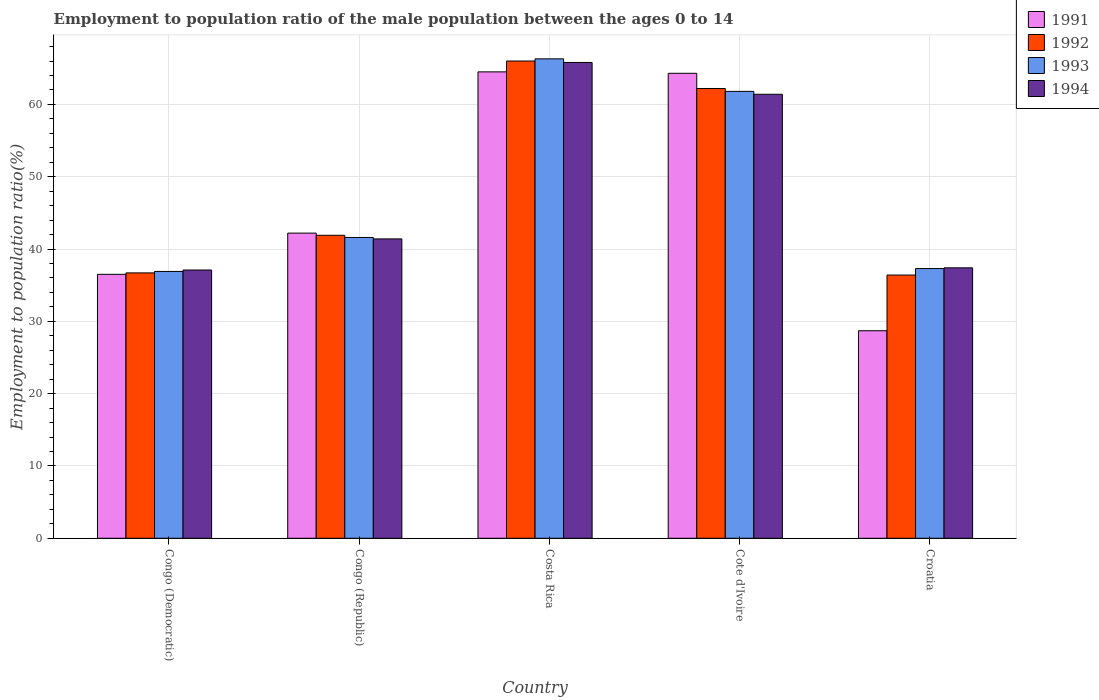How many different coloured bars are there?
Give a very brief answer. 4. Are the number of bars per tick equal to the number of legend labels?
Provide a succinct answer. Yes. What is the label of the 1st group of bars from the left?
Your response must be concise. Congo (Democratic). What is the employment to population ratio in 1992 in Congo (Democratic)?
Keep it short and to the point. 36.7. Across all countries, what is the minimum employment to population ratio in 1992?
Provide a short and direct response. 36.4. In which country was the employment to population ratio in 1993 maximum?
Give a very brief answer. Costa Rica. In which country was the employment to population ratio in 1991 minimum?
Provide a succinct answer. Croatia. What is the total employment to population ratio in 1991 in the graph?
Offer a terse response. 236.2. What is the difference between the employment to population ratio in 1991 in Costa Rica and that in Cote d'Ivoire?
Your answer should be compact. 0.2. What is the difference between the employment to population ratio in 1992 in Croatia and the employment to population ratio in 1991 in Costa Rica?
Give a very brief answer. -28.1. What is the average employment to population ratio in 1994 per country?
Your answer should be compact. 48.62. What is the difference between the employment to population ratio of/in 1994 and employment to population ratio of/in 1992 in Costa Rica?
Provide a short and direct response. -0.2. In how many countries, is the employment to population ratio in 1994 greater than 2 %?
Give a very brief answer. 5. What is the ratio of the employment to population ratio in 1991 in Costa Rica to that in Croatia?
Make the answer very short. 2.25. Is the employment to population ratio in 1992 in Costa Rica less than that in Croatia?
Offer a very short reply. No. What is the difference between the highest and the second highest employment to population ratio in 1991?
Keep it short and to the point. 22.3. What is the difference between the highest and the lowest employment to population ratio in 1993?
Your answer should be very brief. 29.4. Is it the case that in every country, the sum of the employment to population ratio in 1991 and employment to population ratio in 1992 is greater than the sum of employment to population ratio in 1994 and employment to population ratio in 1993?
Your answer should be very brief. No. How many countries are there in the graph?
Give a very brief answer. 5. What is the difference between two consecutive major ticks on the Y-axis?
Your response must be concise. 10. How are the legend labels stacked?
Offer a terse response. Vertical. What is the title of the graph?
Your response must be concise. Employment to population ratio of the male population between the ages 0 to 14. What is the label or title of the Y-axis?
Your answer should be very brief. Employment to population ratio(%). What is the Employment to population ratio(%) in 1991 in Congo (Democratic)?
Make the answer very short. 36.5. What is the Employment to population ratio(%) in 1992 in Congo (Democratic)?
Make the answer very short. 36.7. What is the Employment to population ratio(%) in 1993 in Congo (Democratic)?
Your response must be concise. 36.9. What is the Employment to population ratio(%) in 1994 in Congo (Democratic)?
Your answer should be very brief. 37.1. What is the Employment to population ratio(%) in 1991 in Congo (Republic)?
Offer a very short reply. 42.2. What is the Employment to population ratio(%) of 1992 in Congo (Republic)?
Your response must be concise. 41.9. What is the Employment to population ratio(%) of 1993 in Congo (Republic)?
Ensure brevity in your answer.  41.6. What is the Employment to population ratio(%) in 1994 in Congo (Republic)?
Your response must be concise. 41.4. What is the Employment to population ratio(%) in 1991 in Costa Rica?
Ensure brevity in your answer.  64.5. What is the Employment to population ratio(%) of 1992 in Costa Rica?
Keep it short and to the point. 66. What is the Employment to population ratio(%) in 1993 in Costa Rica?
Ensure brevity in your answer.  66.3. What is the Employment to population ratio(%) in 1994 in Costa Rica?
Offer a terse response. 65.8. What is the Employment to population ratio(%) of 1991 in Cote d'Ivoire?
Provide a short and direct response. 64.3. What is the Employment to population ratio(%) of 1992 in Cote d'Ivoire?
Ensure brevity in your answer.  62.2. What is the Employment to population ratio(%) of 1993 in Cote d'Ivoire?
Offer a very short reply. 61.8. What is the Employment to population ratio(%) in 1994 in Cote d'Ivoire?
Provide a succinct answer. 61.4. What is the Employment to population ratio(%) of 1991 in Croatia?
Provide a short and direct response. 28.7. What is the Employment to population ratio(%) in 1992 in Croatia?
Offer a very short reply. 36.4. What is the Employment to population ratio(%) in 1993 in Croatia?
Your response must be concise. 37.3. What is the Employment to population ratio(%) of 1994 in Croatia?
Your answer should be compact. 37.4. Across all countries, what is the maximum Employment to population ratio(%) of 1991?
Your answer should be very brief. 64.5. Across all countries, what is the maximum Employment to population ratio(%) of 1993?
Your answer should be compact. 66.3. Across all countries, what is the maximum Employment to population ratio(%) of 1994?
Provide a short and direct response. 65.8. Across all countries, what is the minimum Employment to population ratio(%) in 1991?
Your response must be concise. 28.7. Across all countries, what is the minimum Employment to population ratio(%) in 1992?
Your response must be concise. 36.4. Across all countries, what is the minimum Employment to population ratio(%) of 1993?
Ensure brevity in your answer.  36.9. Across all countries, what is the minimum Employment to population ratio(%) of 1994?
Offer a terse response. 37.1. What is the total Employment to population ratio(%) in 1991 in the graph?
Your answer should be compact. 236.2. What is the total Employment to population ratio(%) of 1992 in the graph?
Your answer should be very brief. 243.2. What is the total Employment to population ratio(%) of 1993 in the graph?
Ensure brevity in your answer.  243.9. What is the total Employment to population ratio(%) in 1994 in the graph?
Your response must be concise. 243.1. What is the difference between the Employment to population ratio(%) of 1992 in Congo (Democratic) and that in Congo (Republic)?
Provide a succinct answer. -5.2. What is the difference between the Employment to population ratio(%) of 1991 in Congo (Democratic) and that in Costa Rica?
Provide a short and direct response. -28. What is the difference between the Employment to population ratio(%) of 1992 in Congo (Democratic) and that in Costa Rica?
Offer a very short reply. -29.3. What is the difference between the Employment to population ratio(%) in 1993 in Congo (Democratic) and that in Costa Rica?
Offer a terse response. -29.4. What is the difference between the Employment to population ratio(%) of 1994 in Congo (Democratic) and that in Costa Rica?
Offer a very short reply. -28.7. What is the difference between the Employment to population ratio(%) in 1991 in Congo (Democratic) and that in Cote d'Ivoire?
Your answer should be compact. -27.8. What is the difference between the Employment to population ratio(%) in 1992 in Congo (Democratic) and that in Cote d'Ivoire?
Provide a short and direct response. -25.5. What is the difference between the Employment to population ratio(%) of 1993 in Congo (Democratic) and that in Cote d'Ivoire?
Make the answer very short. -24.9. What is the difference between the Employment to population ratio(%) of 1994 in Congo (Democratic) and that in Cote d'Ivoire?
Provide a succinct answer. -24.3. What is the difference between the Employment to population ratio(%) in 1991 in Congo (Democratic) and that in Croatia?
Your response must be concise. 7.8. What is the difference between the Employment to population ratio(%) of 1993 in Congo (Democratic) and that in Croatia?
Make the answer very short. -0.4. What is the difference between the Employment to population ratio(%) in 1991 in Congo (Republic) and that in Costa Rica?
Provide a succinct answer. -22.3. What is the difference between the Employment to population ratio(%) of 1992 in Congo (Republic) and that in Costa Rica?
Offer a terse response. -24.1. What is the difference between the Employment to population ratio(%) of 1993 in Congo (Republic) and that in Costa Rica?
Ensure brevity in your answer.  -24.7. What is the difference between the Employment to population ratio(%) of 1994 in Congo (Republic) and that in Costa Rica?
Keep it short and to the point. -24.4. What is the difference between the Employment to population ratio(%) in 1991 in Congo (Republic) and that in Cote d'Ivoire?
Provide a short and direct response. -22.1. What is the difference between the Employment to population ratio(%) of 1992 in Congo (Republic) and that in Cote d'Ivoire?
Offer a terse response. -20.3. What is the difference between the Employment to population ratio(%) in 1993 in Congo (Republic) and that in Cote d'Ivoire?
Your answer should be compact. -20.2. What is the difference between the Employment to population ratio(%) of 1992 in Congo (Republic) and that in Croatia?
Your answer should be compact. 5.5. What is the difference between the Employment to population ratio(%) in 1993 in Congo (Republic) and that in Croatia?
Offer a very short reply. 4.3. What is the difference between the Employment to population ratio(%) in 1992 in Costa Rica and that in Cote d'Ivoire?
Provide a succinct answer. 3.8. What is the difference between the Employment to population ratio(%) of 1993 in Costa Rica and that in Cote d'Ivoire?
Ensure brevity in your answer.  4.5. What is the difference between the Employment to population ratio(%) in 1991 in Costa Rica and that in Croatia?
Keep it short and to the point. 35.8. What is the difference between the Employment to population ratio(%) of 1992 in Costa Rica and that in Croatia?
Your response must be concise. 29.6. What is the difference between the Employment to population ratio(%) of 1994 in Costa Rica and that in Croatia?
Ensure brevity in your answer.  28.4. What is the difference between the Employment to population ratio(%) of 1991 in Cote d'Ivoire and that in Croatia?
Ensure brevity in your answer.  35.6. What is the difference between the Employment to population ratio(%) in 1992 in Cote d'Ivoire and that in Croatia?
Provide a short and direct response. 25.8. What is the difference between the Employment to population ratio(%) in 1993 in Cote d'Ivoire and that in Croatia?
Your answer should be compact. 24.5. What is the difference between the Employment to population ratio(%) of 1991 in Congo (Democratic) and the Employment to population ratio(%) of 1992 in Congo (Republic)?
Make the answer very short. -5.4. What is the difference between the Employment to population ratio(%) in 1991 in Congo (Democratic) and the Employment to population ratio(%) in 1993 in Congo (Republic)?
Give a very brief answer. -5.1. What is the difference between the Employment to population ratio(%) of 1992 in Congo (Democratic) and the Employment to population ratio(%) of 1993 in Congo (Republic)?
Your answer should be very brief. -4.9. What is the difference between the Employment to population ratio(%) in 1992 in Congo (Democratic) and the Employment to population ratio(%) in 1994 in Congo (Republic)?
Give a very brief answer. -4.7. What is the difference between the Employment to population ratio(%) of 1991 in Congo (Democratic) and the Employment to population ratio(%) of 1992 in Costa Rica?
Keep it short and to the point. -29.5. What is the difference between the Employment to population ratio(%) of 1991 in Congo (Democratic) and the Employment to population ratio(%) of 1993 in Costa Rica?
Make the answer very short. -29.8. What is the difference between the Employment to population ratio(%) in 1991 in Congo (Democratic) and the Employment to population ratio(%) in 1994 in Costa Rica?
Provide a short and direct response. -29.3. What is the difference between the Employment to population ratio(%) in 1992 in Congo (Democratic) and the Employment to population ratio(%) in 1993 in Costa Rica?
Ensure brevity in your answer.  -29.6. What is the difference between the Employment to population ratio(%) of 1992 in Congo (Democratic) and the Employment to population ratio(%) of 1994 in Costa Rica?
Offer a very short reply. -29.1. What is the difference between the Employment to population ratio(%) of 1993 in Congo (Democratic) and the Employment to population ratio(%) of 1994 in Costa Rica?
Your answer should be very brief. -28.9. What is the difference between the Employment to population ratio(%) of 1991 in Congo (Democratic) and the Employment to population ratio(%) of 1992 in Cote d'Ivoire?
Offer a very short reply. -25.7. What is the difference between the Employment to population ratio(%) of 1991 in Congo (Democratic) and the Employment to population ratio(%) of 1993 in Cote d'Ivoire?
Provide a short and direct response. -25.3. What is the difference between the Employment to population ratio(%) in 1991 in Congo (Democratic) and the Employment to population ratio(%) in 1994 in Cote d'Ivoire?
Offer a terse response. -24.9. What is the difference between the Employment to population ratio(%) in 1992 in Congo (Democratic) and the Employment to population ratio(%) in 1993 in Cote d'Ivoire?
Provide a succinct answer. -25.1. What is the difference between the Employment to population ratio(%) of 1992 in Congo (Democratic) and the Employment to population ratio(%) of 1994 in Cote d'Ivoire?
Provide a succinct answer. -24.7. What is the difference between the Employment to population ratio(%) of 1993 in Congo (Democratic) and the Employment to population ratio(%) of 1994 in Cote d'Ivoire?
Provide a succinct answer. -24.5. What is the difference between the Employment to population ratio(%) in 1991 in Congo (Democratic) and the Employment to population ratio(%) in 1994 in Croatia?
Give a very brief answer. -0.9. What is the difference between the Employment to population ratio(%) in 1992 in Congo (Democratic) and the Employment to population ratio(%) in 1993 in Croatia?
Give a very brief answer. -0.6. What is the difference between the Employment to population ratio(%) in 1992 in Congo (Democratic) and the Employment to population ratio(%) in 1994 in Croatia?
Keep it short and to the point. -0.7. What is the difference between the Employment to population ratio(%) in 1993 in Congo (Democratic) and the Employment to population ratio(%) in 1994 in Croatia?
Your answer should be compact. -0.5. What is the difference between the Employment to population ratio(%) of 1991 in Congo (Republic) and the Employment to population ratio(%) of 1992 in Costa Rica?
Provide a succinct answer. -23.8. What is the difference between the Employment to population ratio(%) in 1991 in Congo (Republic) and the Employment to population ratio(%) in 1993 in Costa Rica?
Your answer should be very brief. -24.1. What is the difference between the Employment to population ratio(%) of 1991 in Congo (Republic) and the Employment to population ratio(%) of 1994 in Costa Rica?
Provide a short and direct response. -23.6. What is the difference between the Employment to population ratio(%) in 1992 in Congo (Republic) and the Employment to population ratio(%) in 1993 in Costa Rica?
Offer a very short reply. -24.4. What is the difference between the Employment to population ratio(%) of 1992 in Congo (Republic) and the Employment to population ratio(%) of 1994 in Costa Rica?
Make the answer very short. -23.9. What is the difference between the Employment to population ratio(%) in 1993 in Congo (Republic) and the Employment to population ratio(%) in 1994 in Costa Rica?
Ensure brevity in your answer.  -24.2. What is the difference between the Employment to population ratio(%) of 1991 in Congo (Republic) and the Employment to population ratio(%) of 1993 in Cote d'Ivoire?
Your answer should be compact. -19.6. What is the difference between the Employment to population ratio(%) of 1991 in Congo (Republic) and the Employment to population ratio(%) of 1994 in Cote d'Ivoire?
Provide a succinct answer. -19.2. What is the difference between the Employment to population ratio(%) of 1992 in Congo (Republic) and the Employment to population ratio(%) of 1993 in Cote d'Ivoire?
Your response must be concise. -19.9. What is the difference between the Employment to population ratio(%) of 1992 in Congo (Republic) and the Employment to population ratio(%) of 1994 in Cote d'Ivoire?
Provide a succinct answer. -19.5. What is the difference between the Employment to population ratio(%) of 1993 in Congo (Republic) and the Employment to population ratio(%) of 1994 in Cote d'Ivoire?
Give a very brief answer. -19.8. What is the difference between the Employment to population ratio(%) in 1991 in Congo (Republic) and the Employment to population ratio(%) in 1992 in Croatia?
Give a very brief answer. 5.8. What is the difference between the Employment to population ratio(%) in 1991 in Congo (Republic) and the Employment to population ratio(%) in 1993 in Croatia?
Offer a very short reply. 4.9. What is the difference between the Employment to population ratio(%) in 1991 in Costa Rica and the Employment to population ratio(%) in 1992 in Cote d'Ivoire?
Provide a succinct answer. 2.3. What is the difference between the Employment to population ratio(%) in 1991 in Costa Rica and the Employment to population ratio(%) in 1993 in Cote d'Ivoire?
Provide a short and direct response. 2.7. What is the difference between the Employment to population ratio(%) in 1991 in Costa Rica and the Employment to population ratio(%) in 1994 in Cote d'Ivoire?
Make the answer very short. 3.1. What is the difference between the Employment to population ratio(%) of 1993 in Costa Rica and the Employment to population ratio(%) of 1994 in Cote d'Ivoire?
Your answer should be very brief. 4.9. What is the difference between the Employment to population ratio(%) in 1991 in Costa Rica and the Employment to population ratio(%) in 1992 in Croatia?
Offer a terse response. 28.1. What is the difference between the Employment to population ratio(%) in 1991 in Costa Rica and the Employment to population ratio(%) in 1993 in Croatia?
Provide a succinct answer. 27.2. What is the difference between the Employment to population ratio(%) in 1991 in Costa Rica and the Employment to population ratio(%) in 1994 in Croatia?
Your answer should be compact. 27.1. What is the difference between the Employment to population ratio(%) of 1992 in Costa Rica and the Employment to population ratio(%) of 1993 in Croatia?
Your answer should be very brief. 28.7. What is the difference between the Employment to population ratio(%) of 1992 in Costa Rica and the Employment to population ratio(%) of 1994 in Croatia?
Provide a short and direct response. 28.6. What is the difference between the Employment to population ratio(%) in 1993 in Costa Rica and the Employment to population ratio(%) in 1994 in Croatia?
Provide a succinct answer. 28.9. What is the difference between the Employment to population ratio(%) in 1991 in Cote d'Ivoire and the Employment to population ratio(%) in 1992 in Croatia?
Give a very brief answer. 27.9. What is the difference between the Employment to population ratio(%) of 1991 in Cote d'Ivoire and the Employment to population ratio(%) of 1993 in Croatia?
Offer a terse response. 27. What is the difference between the Employment to population ratio(%) of 1991 in Cote d'Ivoire and the Employment to population ratio(%) of 1994 in Croatia?
Your answer should be very brief. 26.9. What is the difference between the Employment to population ratio(%) of 1992 in Cote d'Ivoire and the Employment to population ratio(%) of 1993 in Croatia?
Your answer should be compact. 24.9. What is the difference between the Employment to population ratio(%) in 1992 in Cote d'Ivoire and the Employment to population ratio(%) in 1994 in Croatia?
Your response must be concise. 24.8. What is the difference between the Employment to population ratio(%) in 1993 in Cote d'Ivoire and the Employment to population ratio(%) in 1994 in Croatia?
Provide a succinct answer. 24.4. What is the average Employment to population ratio(%) of 1991 per country?
Your answer should be very brief. 47.24. What is the average Employment to population ratio(%) of 1992 per country?
Keep it short and to the point. 48.64. What is the average Employment to population ratio(%) of 1993 per country?
Offer a very short reply. 48.78. What is the average Employment to population ratio(%) in 1994 per country?
Make the answer very short. 48.62. What is the difference between the Employment to population ratio(%) in 1991 and Employment to population ratio(%) in 1992 in Congo (Democratic)?
Provide a succinct answer. -0.2. What is the difference between the Employment to population ratio(%) in 1991 and Employment to population ratio(%) in 1993 in Congo (Democratic)?
Offer a terse response. -0.4. What is the difference between the Employment to population ratio(%) of 1993 and Employment to population ratio(%) of 1994 in Congo (Democratic)?
Your response must be concise. -0.2. What is the difference between the Employment to population ratio(%) in 1991 and Employment to population ratio(%) in 1993 in Congo (Republic)?
Keep it short and to the point. 0.6. What is the difference between the Employment to population ratio(%) in 1991 and Employment to population ratio(%) in 1993 in Costa Rica?
Keep it short and to the point. -1.8. What is the difference between the Employment to population ratio(%) in 1991 and Employment to population ratio(%) in 1994 in Costa Rica?
Ensure brevity in your answer.  -1.3. What is the difference between the Employment to population ratio(%) in 1992 and Employment to population ratio(%) in 1994 in Costa Rica?
Your answer should be compact. 0.2. What is the difference between the Employment to population ratio(%) in 1993 and Employment to population ratio(%) in 1994 in Costa Rica?
Your response must be concise. 0.5. What is the difference between the Employment to population ratio(%) in 1991 and Employment to population ratio(%) in 1992 in Cote d'Ivoire?
Give a very brief answer. 2.1. What is the difference between the Employment to population ratio(%) in 1991 and Employment to population ratio(%) in 1993 in Cote d'Ivoire?
Provide a succinct answer. 2.5. What is the difference between the Employment to population ratio(%) of 1992 and Employment to population ratio(%) of 1993 in Cote d'Ivoire?
Your answer should be very brief. 0.4. What is the difference between the Employment to population ratio(%) in 1993 and Employment to population ratio(%) in 1994 in Cote d'Ivoire?
Provide a succinct answer. 0.4. What is the difference between the Employment to population ratio(%) of 1991 and Employment to population ratio(%) of 1992 in Croatia?
Your answer should be very brief. -7.7. What is the difference between the Employment to population ratio(%) in 1991 and Employment to population ratio(%) in 1994 in Croatia?
Keep it short and to the point. -8.7. What is the ratio of the Employment to population ratio(%) in 1991 in Congo (Democratic) to that in Congo (Republic)?
Offer a terse response. 0.86. What is the ratio of the Employment to population ratio(%) of 1992 in Congo (Democratic) to that in Congo (Republic)?
Make the answer very short. 0.88. What is the ratio of the Employment to population ratio(%) of 1993 in Congo (Democratic) to that in Congo (Republic)?
Ensure brevity in your answer.  0.89. What is the ratio of the Employment to population ratio(%) in 1994 in Congo (Democratic) to that in Congo (Republic)?
Provide a short and direct response. 0.9. What is the ratio of the Employment to population ratio(%) in 1991 in Congo (Democratic) to that in Costa Rica?
Give a very brief answer. 0.57. What is the ratio of the Employment to population ratio(%) in 1992 in Congo (Democratic) to that in Costa Rica?
Make the answer very short. 0.56. What is the ratio of the Employment to population ratio(%) of 1993 in Congo (Democratic) to that in Costa Rica?
Your response must be concise. 0.56. What is the ratio of the Employment to population ratio(%) of 1994 in Congo (Democratic) to that in Costa Rica?
Offer a terse response. 0.56. What is the ratio of the Employment to population ratio(%) in 1991 in Congo (Democratic) to that in Cote d'Ivoire?
Your answer should be very brief. 0.57. What is the ratio of the Employment to population ratio(%) in 1992 in Congo (Democratic) to that in Cote d'Ivoire?
Ensure brevity in your answer.  0.59. What is the ratio of the Employment to population ratio(%) in 1993 in Congo (Democratic) to that in Cote d'Ivoire?
Provide a succinct answer. 0.6. What is the ratio of the Employment to population ratio(%) of 1994 in Congo (Democratic) to that in Cote d'Ivoire?
Keep it short and to the point. 0.6. What is the ratio of the Employment to population ratio(%) of 1991 in Congo (Democratic) to that in Croatia?
Offer a very short reply. 1.27. What is the ratio of the Employment to population ratio(%) of 1992 in Congo (Democratic) to that in Croatia?
Give a very brief answer. 1.01. What is the ratio of the Employment to population ratio(%) in 1993 in Congo (Democratic) to that in Croatia?
Provide a succinct answer. 0.99. What is the ratio of the Employment to population ratio(%) in 1994 in Congo (Democratic) to that in Croatia?
Offer a terse response. 0.99. What is the ratio of the Employment to population ratio(%) in 1991 in Congo (Republic) to that in Costa Rica?
Make the answer very short. 0.65. What is the ratio of the Employment to population ratio(%) in 1992 in Congo (Republic) to that in Costa Rica?
Make the answer very short. 0.63. What is the ratio of the Employment to population ratio(%) in 1993 in Congo (Republic) to that in Costa Rica?
Provide a short and direct response. 0.63. What is the ratio of the Employment to population ratio(%) of 1994 in Congo (Republic) to that in Costa Rica?
Provide a short and direct response. 0.63. What is the ratio of the Employment to population ratio(%) in 1991 in Congo (Republic) to that in Cote d'Ivoire?
Offer a very short reply. 0.66. What is the ratio of the Employment to population ratio(%) in 1992 in Congo (Republic) to that in Cote d'Ivoire?
Give a very brief answer. 0.67. What is the ratio of the Employment to population ratio(%) of 1993 in Congo (Republic) to that in Cote d'Ivoire?
Ensure brevity in your answer.  0.67. What is the ratio of the Employment to population ratio(%) of 1994 in Congo (Republic) to that in Cote d'Ivoire?
Your answer should be very brief. 0.67. What is the ratio of the Employment to population ratio(%) of 1991 in Congo (Republic) to that in Croatia?
Provide a succinct answer. 1.47. What is the ratio of the Employment to population ratio(%) of 1992 in Congo (Republic) to that in Croatia?
Your answer should be very brief. 1.15. What is the ratio of the Employment to population ratio(%) of 1993 in Congo (Republic) to that in Croatia?
Your answer should be very brief. 1.12. What is the ratio of the Employment to population ratio(%) of 1994 in Congo (Republic) to that in Croatia?
Your answer should be very brief. 1.11. What is the ratio of the Employment to population ratio(%) in 1992 in Costa Rica to that in Cote d'Ivoire?
Give a very brief answer. 1.06. What is the ratio of the Employment to population ratio(%) of 1993 in Costa Rica to that in Cote d'Ivoire?
Offer a terse response. 1.07. What is the ratio of the Employment to population ratio(%) of 1994 in Costa Rica to that in Cote d'Ivoire?
Ensure brevity in your answer.  1.07. What is the ratio of the Employment to population ratio(%) in 1991 in Costa Rica to that in Croatia?
Give a very brief answer. 2.25. What is the ratio of the Employment to population ratio(%) in 1992 in Costa Rica to that in Croatia?
Make the answer very short. 1.81. What is the ratio of the Employment to population ratio(%) in 1993 in Costa Rica to that in Croatia?
Keep it short and to the point. 1.78. What is the ratio of the Employment to population ratio(%) of 1994 in Costa Rica to that in Croatia?
Make the answer very short. 1.76. What is the ratio of the Employment to population ratio(%) in 1991 in Cote d'Ivoire to that in Croatia?
Keep it short and to the point. 2.24. What is the ratio of the Employment to population ratio(%) in 1992 in Cote d'Ivoire to that in Croatia?
Provide a short and direct response. 1.71. What is the ratio of the Employment to population ratio(%) of 1993 in Cote d'Ivoire to that in Croatia?
Keep it short and to the point. 1.66. What is the ratio of the Employment to population ratio(%) of 1994 in Cote d'Ivoire to that in Croatia?
Offer a terse response. 1.64. What is the difference between the highest and the second highest Employment to population ratio(%) of 1992?
Make the answer very short. 3.8. What is the difference between the highest and the lowest Employment to population ratio(%) in 1991?
Offer a very short reply. 35.8. What is the difference between the highest and the lowest Employment to population ratio(%) in 1992?
Keep it short and to the point. 29.6. What is the difference between the highest and the lowest Employment to population ratio(%) in 1993?
Ensure brevity in your answer.  29.4. What is the difference between the highest and the lowest Employment to population ratio(%) in 1994?
Offer a terse response. 28.7. 